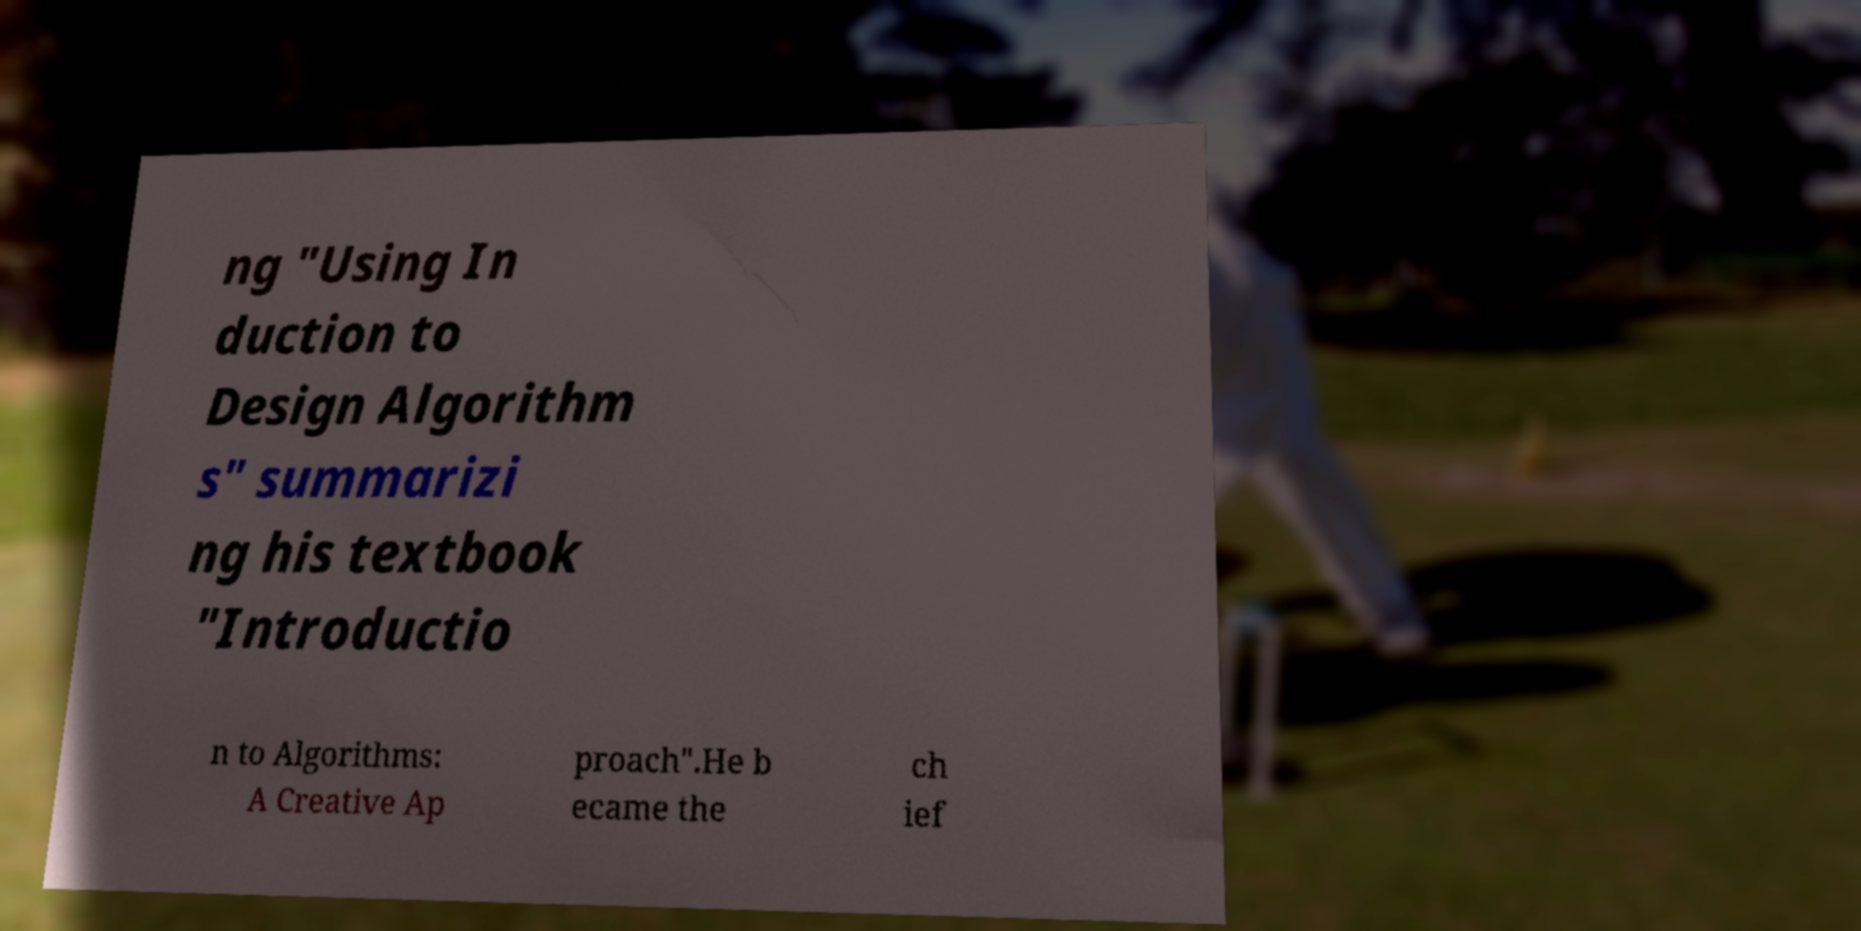Can you read and provide the text displayed in the image?This photo seems to have some interesting text. Can you extract and type it out for me? ng "Using In duction to Design Algorithm s" summarizi ng his textbook "Introductio n to Algorithms: A Creative Ap proach".He b ecame the ch ief 